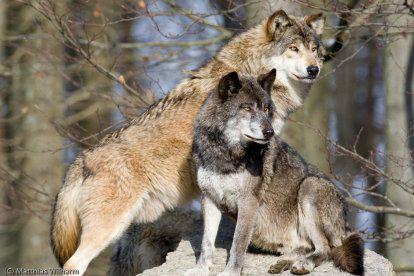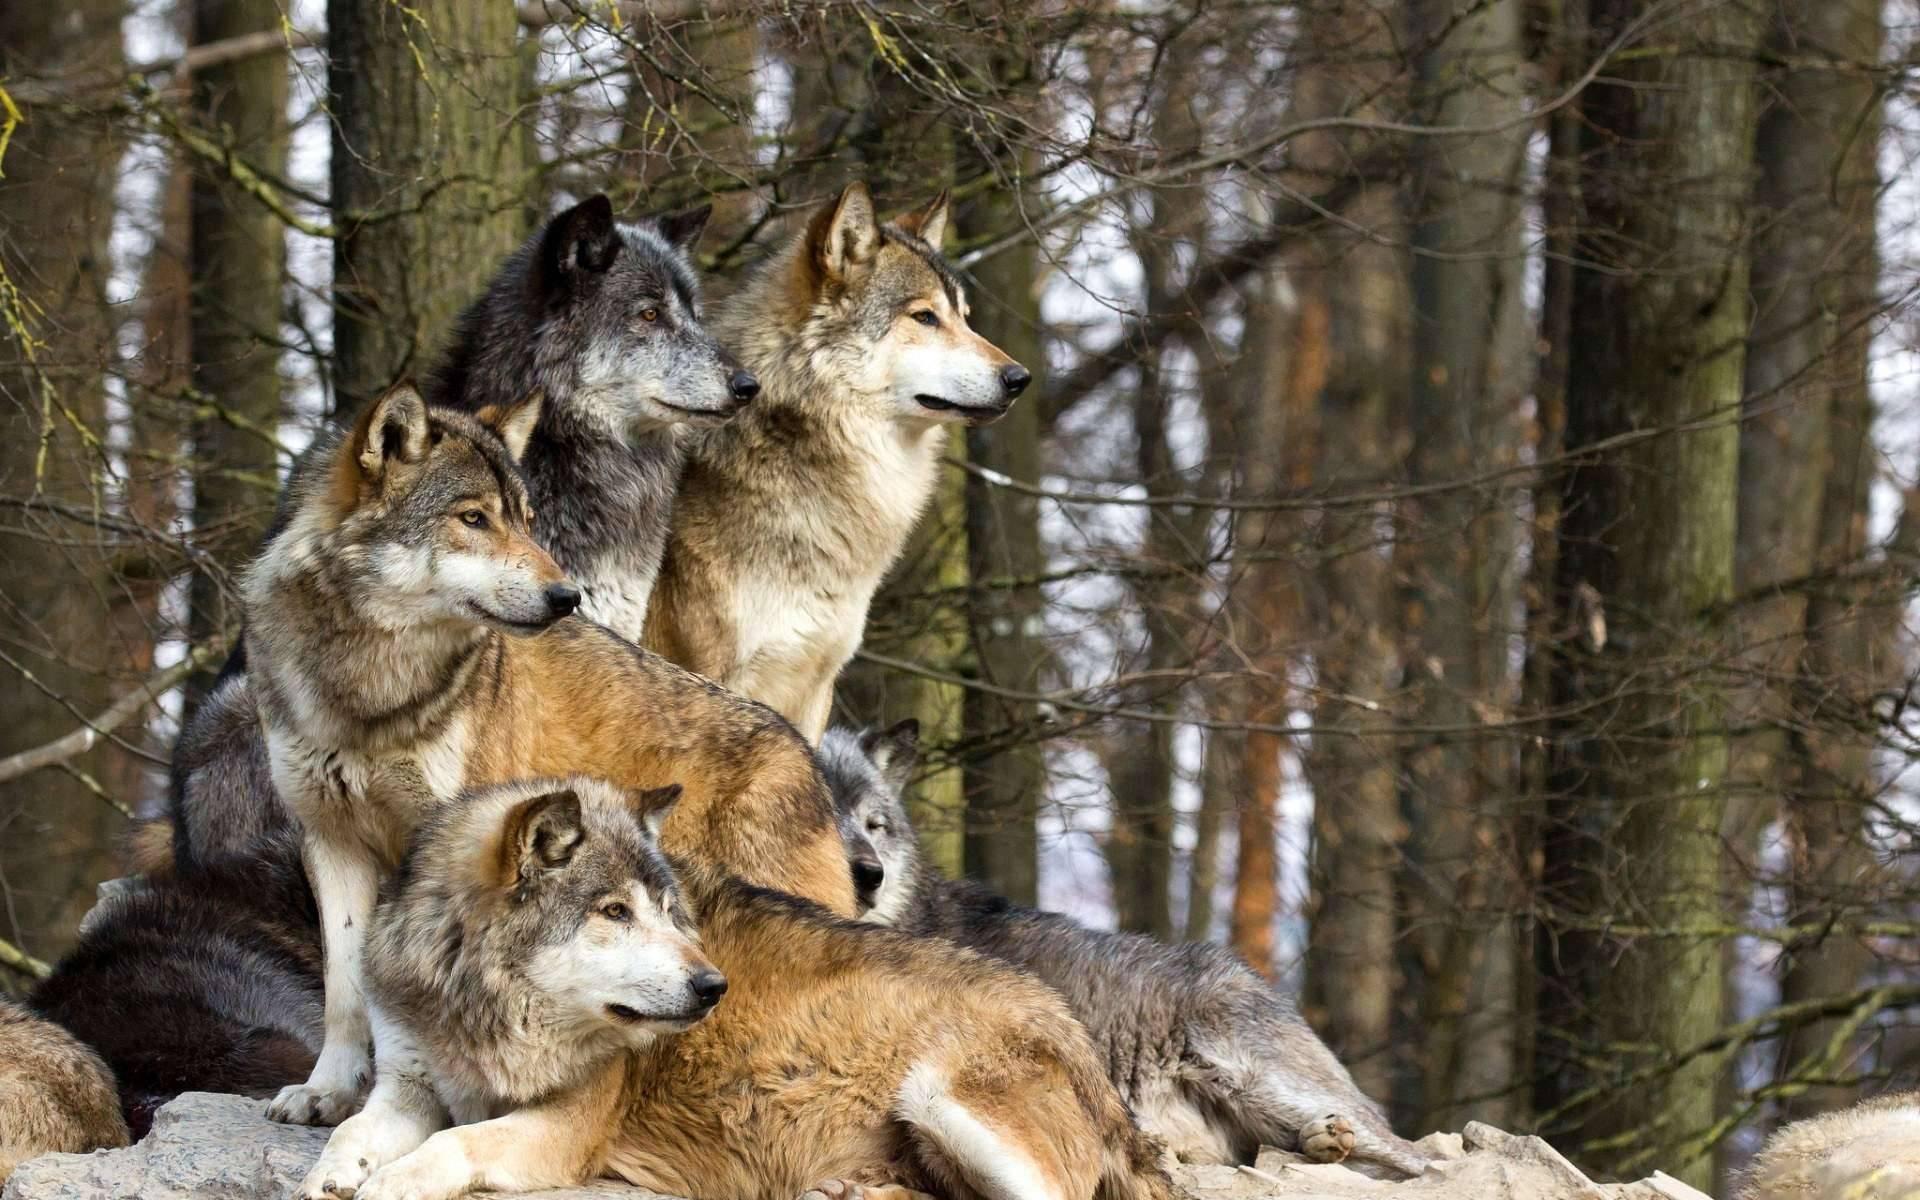The first image is the image on the left, the second image is the image on the right. Analyze the images presented: Is the assertion "In total, no more than four wolves are visible." valid? Answer yes or no. No. The first image is the image on the left, the second image is the image on the right. Evaluate the accuracy of this statement regarding the images: "There are at least five wolves.". Is it true? Answer yes or no. Yes. 